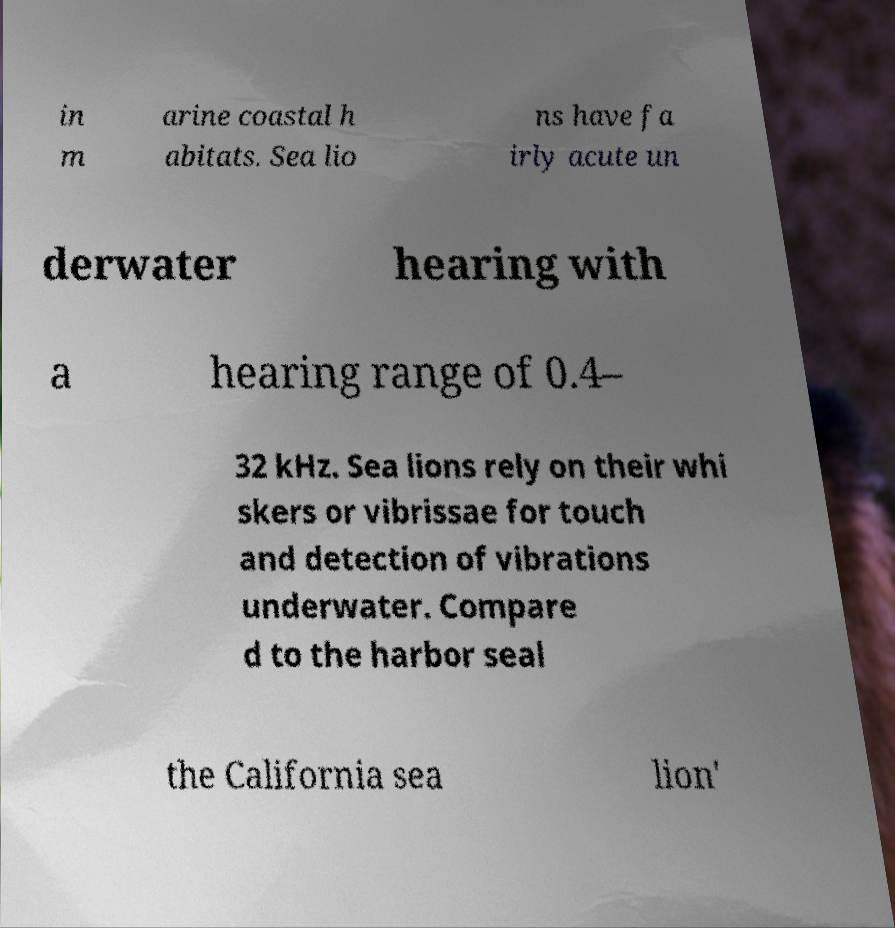Please identify and transcribe the text found in this image. in m arine coastal h abitats. Sea lio ns have fa irly acute un derwater hearing with a hearing range of 0.4– 32 kHz. Sea lions rely on their whi skers or vibrissae for touch and detection of vibrations underwater. Compare d to the harbor seal the California sea lion' 